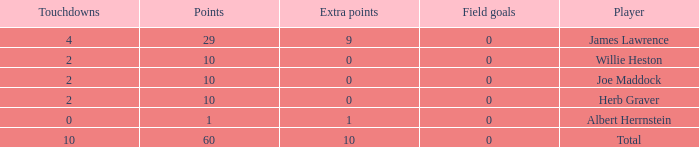What is the highest number of points for players with less than 2 touchdowns and 0 extra points? None. 